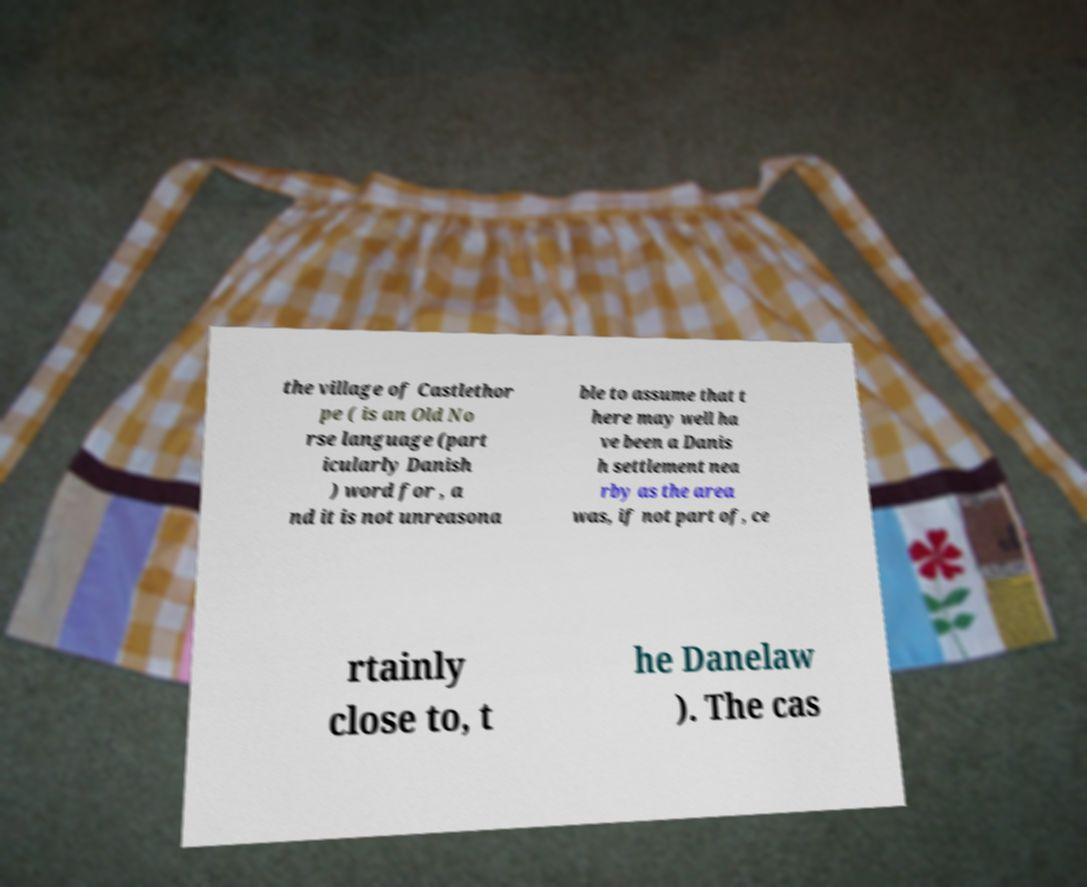What messages or text are displayed in this image? I need them in a readable, typed format. the village of Castlethor pe ( is an Old No rse language (part icularly Danish ) word for , a nd it is not unreasona ble to assume that t here may well ha ve been a Danis h settlement nea rby as the area was, if not part of, ce rtainly close to, t he Danelaw ). The cas 